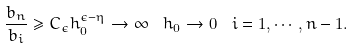Convert formula to latex. <formula><loc_0><loc_0><loc_500><loc_500>\frac { b _ { n } } { b _ { i } } \geq C _ { \epsilon } h _ { 0 } ^ { \epsilon - \eta } \rightarrow \infty \ \ h _ { 0 } \rightarrow 0 \ \ i = 1 , \cdots , n - 1 .</formula> 